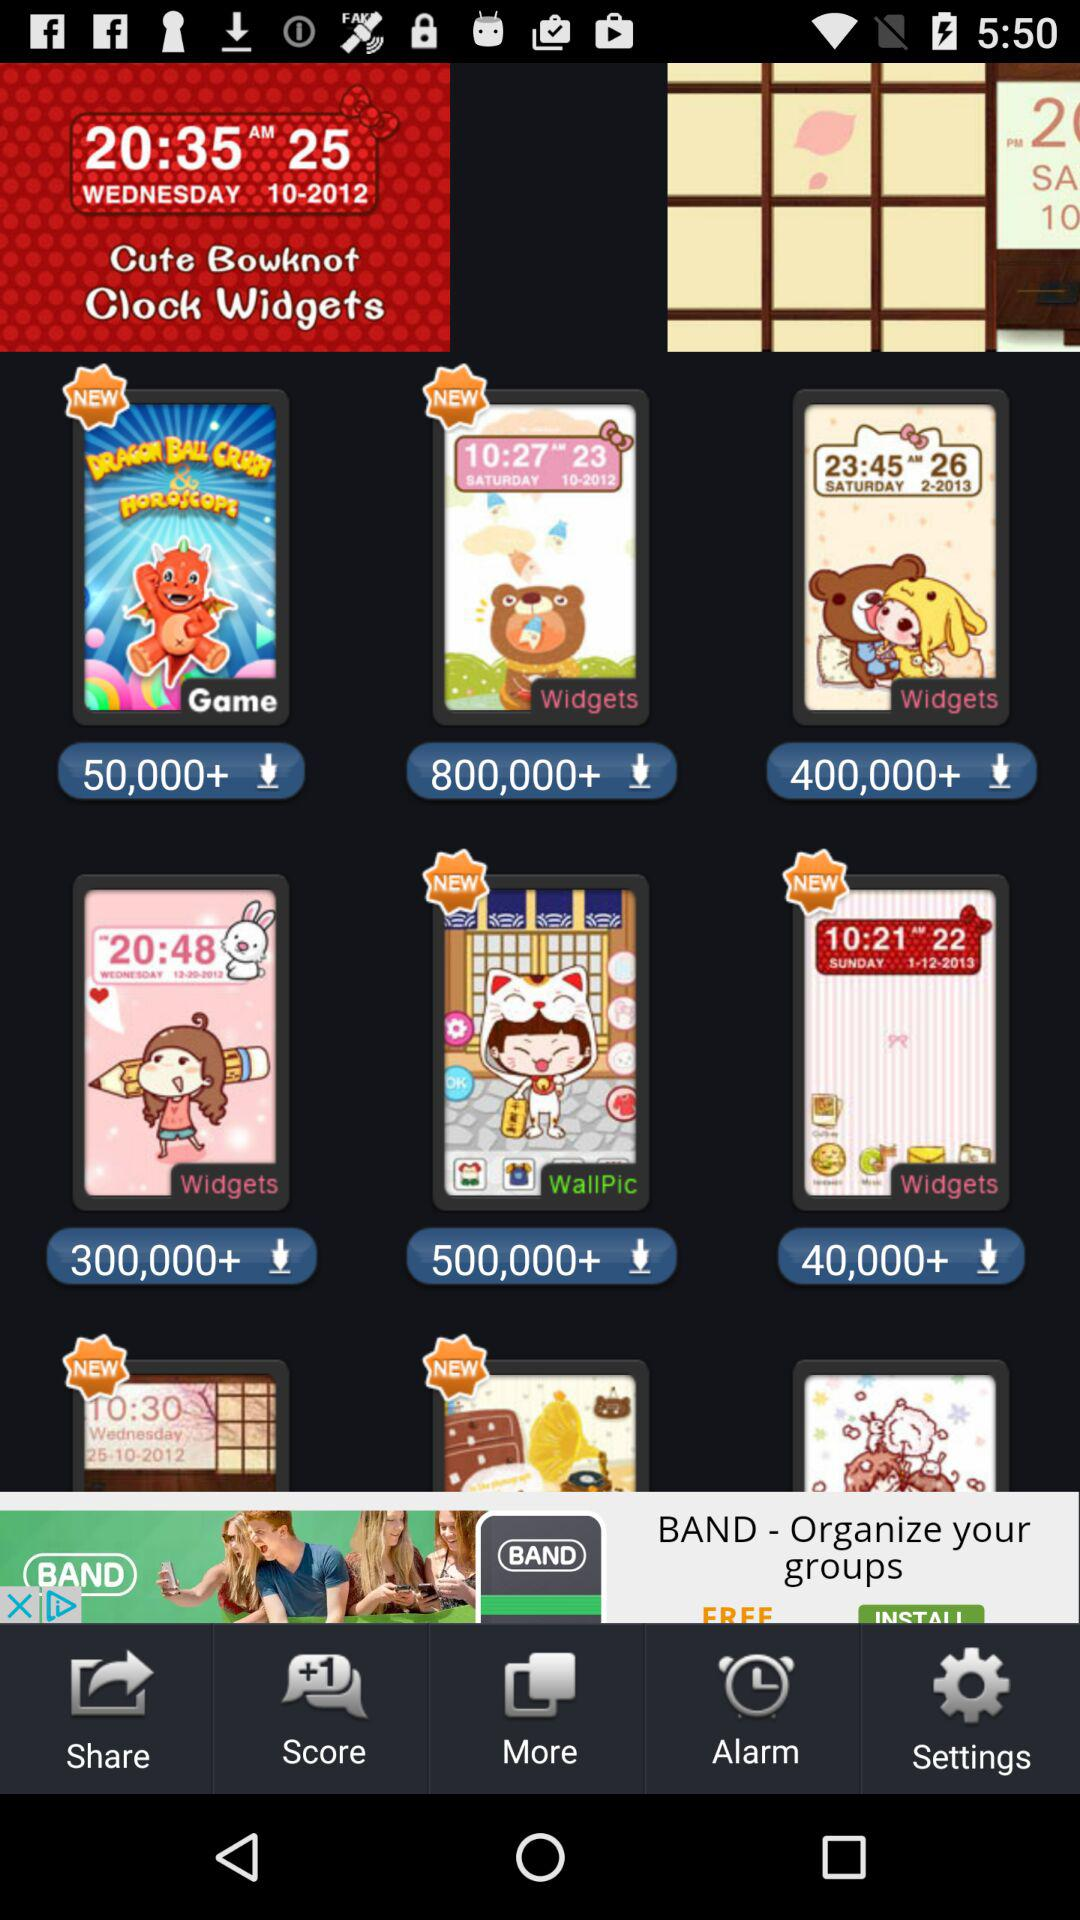How many people downloaded "DRAGON BALL CRUSH & HOROSCOPE"? There were more than 50,000 people who downloaded "DRAGON BALL CRUSH & HOROSCOPE". 